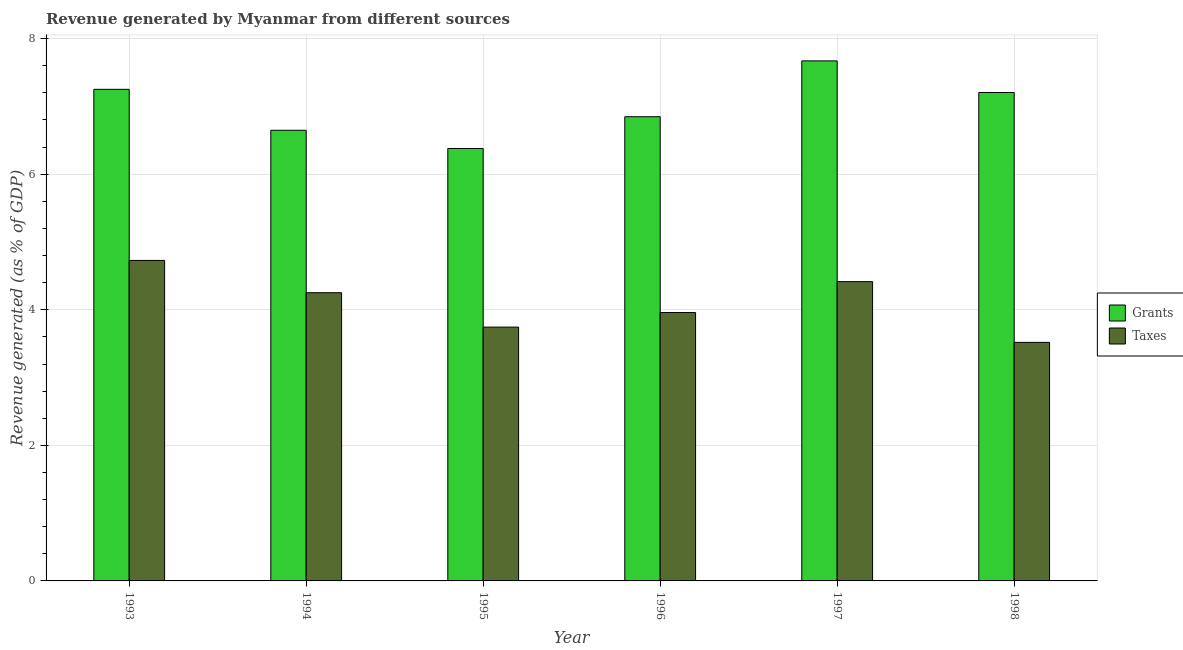How many different coloured bars are there?
Offer a terse response. 2. Are the number of bars on each tick of the X-axis equal?
Provide a short and direct response. Yes. How many bars are there on the 6th tick from the right?
Provide a short and direct response. 2. In how many cases, is the number of bars for a given year not equal to the number of legend labels?
Your answer should be compact. 0. What is the revenue generated by grants in 1995?
Your answer should be compact. 6.38. Across all years, what is the maximum revenue generated by grants?
Ensure brevity in your answer.  7.67. Across all years, what is the minimum revenue generated by grants?
Your answer should be very brief. 6.38. In which year was the revenue generated by taxes maximum?
Your response must be concise. 1993. In which year was the revenue generated by grants minimum?
Offer a terse response. 1995. What is the total revenue generated by grants in the graph?
Make the answer very short. 42. What is the difference between the revenue generated by taxes in 1995 and that in 1997?
Give a very brief answer. -0.67. What is the difference between the revenue generated by taxes in 1993 and the revenue generated by grants in 1995?
Make the answer very short. 0.98. What is the average revenue generated by taxes per year?
Your answer should be compact. 4.1. In the year 1995, what is the difference between the revenue generated by taxes and revenue generated by grants?
Make the answer very short. 0. What is the ratio of the revenue generated by grants in 1996 to that in 1998?
Give a very brief answer. 0.95. Is the difference between the revenue generated by grants in 1993 and 1994 greater than the difference between the revenue generated by taxes in 1993 and 1994?
Give a very brief answer. No. What is the difference between the highest and the second highest revenue generated by grants?
Offer a very short reply. 0.42. What is the difference between the highest and the lowest revenue generated by taxes?
Ensure brevity in your answer.  1.21. What does the 1st bar from the left in 1993 represents?
Offer a terse response. Grants. What does the 1st bar from the right in 1993 represents?
Keep it short and to the point. Taxes. How many bars are there?
Offer a very short reply. 12. How many legend labels are there?
Offer a terse response. 2. What is the title of the graph?
Offer a very short reply. Revenue generated by Myanmar from different sources. What is the label or title of the Y-axis?
Your answer should be compact. Revenue generated (as % of GDP). What is the Revenue generated (as % of GDP) in Grants in 1993?
Make the answer very short. 7.25. What is the Revenue generated (as % of GDP) of Taxes in 1993?
Offer a terse response. 4.73. What is the Revenue generated (as % of GDP) of Grants in 1994?
Your response must be concise. 6.65. What is the Revenue generated (as % of GDP) of Taxes in 1994?
Keep it short and to the point. 4.25. What is the Revenue generated (as % of GDP) in Grants in 1995?
Keep it short and to the point. 6.38. What is the Revenue generated (as % of GDP) of Taxes in 1995?
Your answer should be compact. 3.74. What is the Revenue generated (as % of GDP) of Grants in 1996?
Offer a very short reply. 6.85. What is the Revenue generated (as % of GDP) of Taxes in 1996?
Make the answer very short. 3.96. What is the Revenue generated (as % of GDP) of Grants in 1997?
Your answer should be compact. 7.67. What is the Revenue generated (as % of GDP) of Taxes in 1997?
Offer a terse response. 4.42. What is the Revenue generated (as % of GDP) in Grants in 1998?
Offer a very short reply. 7.21. What is the Revenue generated (as % of GDP) of Taxes in 1998?
Offer a terse response. 3.52. Across all years, what is the maximum Revenue generated (as % of GDP) in Grants?
Offer a very short reply. 7.67. Across all years, what is the maximum Revenue generated (as % of GDP) of Taxes?
Ensure brevity in your answer.  4.73. Across all years, what is the minimum Revenue generated (as % of GDP) in Grants?
Your answer should be very brief. 6.38. Across all years, what is the minimum Revenue generated (as % of GDP) of Taxes?
Ensure brevity in your answer.  3.52. What is the total Revenue generated (as % of GDP) of Grants in the graph?
Your response must be concise. 42. What is the total Revenue generated (as % of GDP) of Taxes in the graph?
Offer a terse response. 24.62. What is the difference between the Revenue generated (as % of GDP) in Grants in 1993 and that in 1994?
Give a very brief answer. 0.6. What is the difference between the Revenue generated (as % of GDP) in Taxes in 1993 and that in 1994?
Ensure brevity in your answer.  0.48. What is the difference between the Revenue generated (as % of GDP) of Grants in 1993 and that in 1995?
Make the answer very short. 0.87. What is the difference between the Revenue generated (as % of GDP) of Taxes in 1993 and that in 1995?
Offer a very short reply. 0.98. What is the difference between the Revenue generated (as % of GDP) of Grants in 1993 and that in 1996?
Ensure brevity in your answer.  0.4. What is the difference between the Revenue generated (as % of GDP) of Taxes in 1993 and that in 1996?
Offer a terse response. 0.77. What is the difference between the Revenue generated (as % of GDP) in Grants in 1993 and that in 1997?
Provide a succinct answer. -0.42. What is the difference between the Revenue generated (as % of GDP) of Taxes in 1993 and that in 1997?
Make the answer very short. 0.31. What is the difference between the Revenue generated (as % of GDP) in Grants in 1993 and that in 1998?
Give a very brief answer. 0.05. What is the difference between the Revenue generated (as % of GDP) in Taxes in 1993 and that in 1998?
Provide a succinct answer. 1.21. What is the difference between the Revenue generated (as % of GDP) in Grants in 1994 and that in 1995?
Offer a terse response. 0.27. What is the difference between the Revenue generated (as % of GDP) of Taxes in 1994 and that in 1995?
Give a very brief answer. 0.51. What is the difference between the Revenue generated (as % of GDP) in Grants in 1994 and that in 1996?
Your response must be concise. -0.2. What is the difference between the Revenue generated (as % of GDP) in Taxes in 1994 and that in 1996?
Your answer should be compact. 0.29. What is the difference between the Revenue generated (as % of GDP) in Grants in 1994 and that in 1997?
Offer a very short reply. -1.02. What is the difference between the Revenue generated (as % of GDP) in Taxes in 1994 and that in 1997?
Give a very brief answer. -0.16. What is the difference between the Revenue generated (as % of GDP) of Grants in 1994 and that in 1998?
Provide a succinct answer. -0.56. What is the difference between the Revenue generated (as % of GDP) in Taxes in 1994 and that in 1998?
Your response must be concise. 0.73. What is the difference between the Revenue generated (as % of GDP) in Grants in 1995 and that in 1996?
Give a very brief answer. -0.47. What is the difference between the Revenue generated (as % of GDP) of Taxes in 1995 and that in 1996?
Make the answer very short. -0.21. What is the difference between the Revenue generated (as % of GDP) in Grants in 1995 and that in 1997?
Provide a succinct answer. -1.29. What is the difference between the Revenue generated (as % of GDP) in Taxes in 1995 and that in 1997?
Your answer should be compact. -0.67. What is the difference between the Revenue generated (as % of GDP) in Grants in 1995 and that in 1998?
Your answer should be compact. -0.83. What is the difference between the Revenue generated (as % of GDP) of Taxes in 1995 and that in 1998?
Offer a very short reply. 0.23. What is the difference between the Revenue generated (as % of GDP) of Grants in 1996 and that in 1997?
Your answer should be very brief. -0.82. What is the difference between the Revenue generated (as % of GDP) of Taxes in 1996 and that in 1997?
Give a very brief answer. -0.46. What is the difference between the Revenue generated (as % of GDP) of Grants in 1996 and that in 1998?
Your response must be concise. -0.36. What is the difference between the Revenue generated (as % of GDP) in Taxes in 1996 and that in 1998?
Your response must be concise. 0.44. What is the difference between the Revenue generated (as % of GDP) of Grants in 1997 and that in 1998?
Provide a succinct answer. 0.47. What is the difference between the Revenue generated (as % of GDP) of Taxes in 1997 and that in 1998?
Keep it short and to the point. 0.9. What is the difference between the Revenue generated (as % of GDP) in Grants in 1993 and the Revenue generated (as % of GDP) in Taxes in 1994?
Provide a short and direct response. 3. What is the difference between the Revenue generated (as % of GDP) in Grants in 1993 and the Revenue generated (as % of GDP) in Taxes in 1995?
Offer a very short reply. 3.51. What is the difference between the Revenue generated (as % of GDP) in Grants in 1993 and the Revenue generated (as % of GDP) in Taxes in 1996?
Offer a terse response. 3.29. What is the difference between the Revenue generated (as % of GDP) in Grants in 1993 and the Revenue generated (as % of GDP) in Taxes in 1997?
Make the answer very short. 2.84. What is the difference between the Revenue generated (as % of GDP) of Grants in 1993 and the Revenue generated (as % of GDP) of Taxes in 1998?
Offer a terse response. 3.73. What is the difference between the Revenue generated (as % of GDP) in Grants in 1994 and the Revenue generated (as % of GDP) in Taxes in 1995?
Ensure brevity in your answer.  2.9. What is the difference between the Revenue generated (as % of GDP) in Grants in 1994 and the Revenue generated (as % of GDP) in Taxes in 1996?
Your answer should be compact. 2.69. What is the difference between the Revenue generated (as % of GDP) in Grants in 1994 and the Revenue generated (as % of GDP) in Taxes in 1997?
Your answer should be very brief. 2.23. What is the difference between the Revenue generated (as % of GDP) of Grants in 1994 and the Revenue generated (as % of GDP) of Taxes in 1998?
Provide a succinct answer. 3.13. What is the difference between the Revenue generated (as % of GDP) of Grants in 1995 and the Revenue generated (as % of GDP) of Taxes in 1996?
Make the answer very short. 2.42. What is the difference between the Revenue generated (as % of GDP) in Grants in 1995 and the Revenue generated (as % of GDP) in Taxes in 1997?
Offer a terse response. 1.96. What is the difference between the Revenue generated (as % of GDP) of Grants in 1995 and the Revenue generated (as % of GDP) of Taxes in 1998?
Provide a succinct answer. 2.86. What is the difference between the Revenue generated (as % of GDP) in Grants in 1996 and the Revenue generated (as % of GDP) in Taxes in 1997?
Your answer should be compact. 2.43. What is the difference between the Revenue generated (as % of GDP) of Grants in 1996 and the Revenue generated (as % of GDP) of Taxes in 1998?
Make the answer very short. 3.33. What is the difference between the Revenue generated (as % of GDP) in Grants in 1997 and the Revenue generated (as % of GDP) in Taxes in 1998?
Provide a succinct answer. 4.15. What is the average Revenue generated (as % of GDP) of Grants per year?
Ensure brevity in your answer.  7. What is the average Revenue generated (as % of GDP) of Taxes per year?
Provide a succinct answer. 4.1. In the year 1993, what is the difference between the Revenue generated (as % of GDP) in Grants and Revenue generated (as % of GDP) in Taxes?
Give a very brief answer. 2.52. In the year 1994, what is the difference between the Revenue generated (as % of GDP) of Grants and Revenue generated (as % of GDP) of Taxes?
Provide a succinct answer. 2.4. In the year 1995, what is the difference between the Revenue generated (as % of GDP) in Grants and Revenue generated (as % of GDP) in Taxes?
Keep it short and to the point. 2.63. In the year 1996, what is the difference between the Revenue generated (as % of GDP) in Grants and Revenue generated (as % of GDP) in Taxes?
Make the answer very short. 2.89. In the year 1997, what is the difference between the Revenue generated (as % of GDP) of Grants and Revenue generated (as % of GDP) of Taxes?
Offer a very short reply. 3.26. In the year 1998, what is the difference between the Revenue generated (as % of GDP) in Grants and Revenue generated (as % of GDP) in Taxes?
Your answer should be very brief. 3.69. What is the ratio of the Revenue generated (as % of GDP) in Taxes in 1993 to that in 1994?
Offer a very short reply. 1.11. What is the ratio of the Revenue generated (as % of GDP) in Grants in 1993 to that in 1995?
Your answer should be compact. 1.14. What is the ratio of the Revenue generated (as % of GDP) of Taxes in 1993 to that in 1995?
Your answer should be compact. 1.26. What is the ratio of the Revenue generated (as % of GDP) of Grants in 1993 to that in 1996?
Make the answer very short. 1.06. What is the ratio of the Revenue generated (as % of GDP) of Taxes in 1993 to that in 1996?
Your response must be concise. 1.19. What is the ratio of the Revenue generated (as % of GDP) in Grants in 1993 to that in 1997?
Keep it short and to the point. 0.95. What is the ratio of the Revenue generated (as % of GDP) in Taxes in 1993 to that in 1997?
Offer a very short reply. 1.07. What is the ratio of the Revenue generated (as % of GDP) of Taxes in 1993 to that in 1998?
Give a very brief answer. 1.34. What is the ratio of the Revenue generated (as % of GDP) of Grants in 1994 to that in 1995?
Give a very brief answer. 1.04. What is the ratio of the Revenue generated (as % of GDP) of Taxes in 1994 to that in 1995?
Offer a terse response. 1.14. What is the ratio of the Revenue generated (as % of GDP) of Grants in 1994 to that in 1996?
Your response must be concise. 0.97. What is the ratio of the Revenue generated (as % of GDP) in Taxes in 1994 to that in 1996?
Your answer should be compact. 1.07. What is the ratio of the Revenue generated (as % of GDP) in Grants in 1994 to that in 1997?
Provide a short and direct response. 0.87. What is the ratio of the Revenue generated (as % of GDP) in Grants in 1994 to that in 1998?
Provide a succinct answer. 0.92. What is the ratio of the Revenue generated (as % of GDP) in Taxes in 1994 to that in 1998?
Make the answer very short. 1.21. What is the ratio of the Revenue generated (as % of GDP) in Grants in 1995 to that in 1996?
Give a very brief answer. 0.93. What is the ratio of the Revenue generated (as % of GDP) in Taxes in 1995 to that in 1996?
Give a very brief answer. 0.95. What is the ratio of the Revenue generated (as % of GDP) in Grants in 1995 to that in 1997?
Ensure brevity in your answer.  0.83. What is the ratio of the Revenue generated (as % of GDP) of Taxes in 1995 to that in 1997?
Offer a terse response. 0.85. What is the ratio of the Revenue generated (as % of GDP) of Grants in 1995 to that in 1998?
Give a very brief answer. 0.89. What is the ratio of the Revenue generated (as % of GDP) in Taxes in 1995 to that in 1998?
Your response must be concise. 1.06. What is the ratio of the Revenue generated (as % of GDP) of Grants in 1996 to that in 1997?
Your response must be concise. 0.89. What is the ratio of the Revenue generated (as % of GDP) in Taxes in 1996 to that in 1997?
Offer a very short reply. 0.9. What is the ratio of the Revenue generated (as % of GDP) of Grants in 1996 to that in 1998?
Give a very brief answer. 0.95. What is the ratio of the Revenue generated (as % of GDP) of Taxes in 1996 to that in 1998?
Keep it short and to the point. 1.12. What is the ratio of the Revenue generated (as % of GDP) in Grants in 1997 to that in 1998?
Provide a short and direct response. 1.06. What is the ratio of the Revenue generated (as % of GDP) of Taxes in 1997 to that in 1998?
Offer a very short reply. 1.25. What is the difference between the highest and the second highest Revenue generated (as % of GDP) of Grants?
Make the answer very short. 0.42. What is the difference between the highest and the second highest Revenue generated (as % of GDP) of Taxes?
Provide a short and direct response. 0.31. What is the difference between the highest and the lowest Revenue generated (as % of GDP) in Grants?
Your answer should be compact. 1.29. What is the difference between the highest and the lowest Revenue generated (as % of GDP) of Taxes?
Your answer should be very brief. 1.21. 